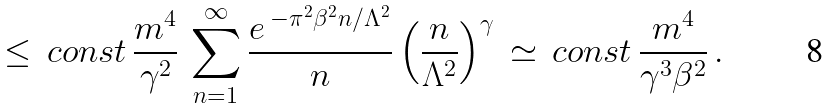<formula> <loc_0><loc_0><loc_500><loc_500>\leq \, c o n s t \, \frac { m ^ { 4 } } { \gamma ^ { 2 } } \, \sum _ { n = 1 } ^ { \infty } \frac { e \, ^ { - \pi ^ { 2 } \beta ^ { 2 } n / \Lambda ^ { 2 } } } { n } \left ( \frac { n } { \Lambda ^ { 2 } } \right ) ^ { \gamma } \, \simeq \, c o n s t \, \frac { m ^ { 4 } } { \gamma ^ { 3 } \beta ^ { 2 } } \, .</formula> 